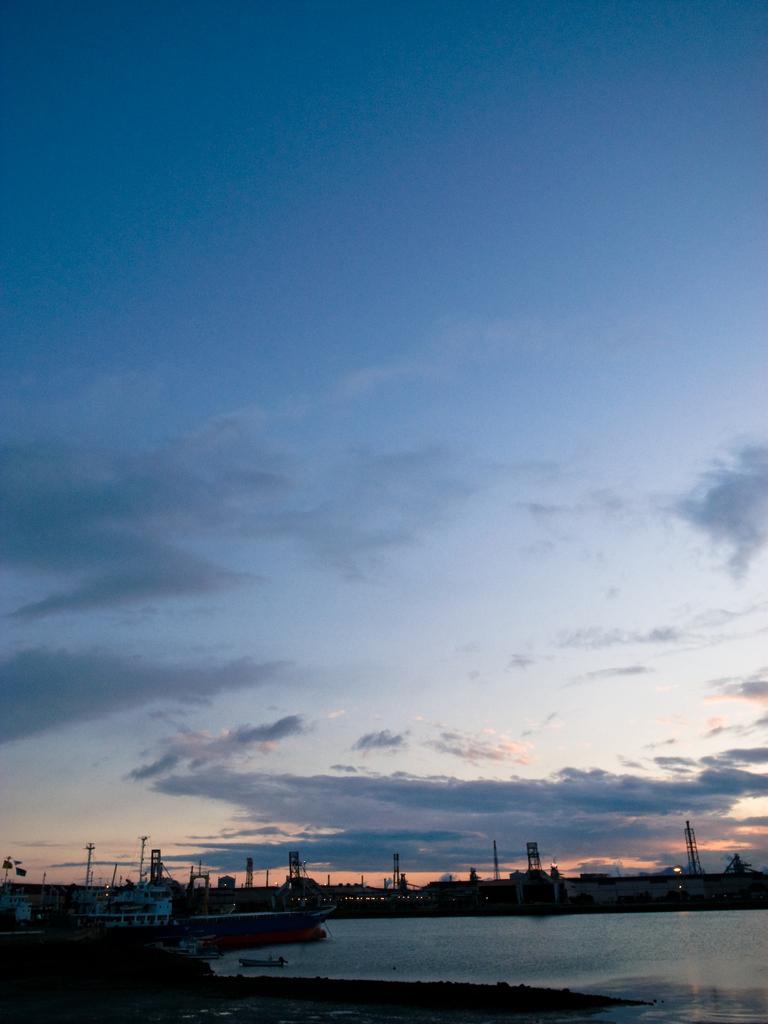How would you summarize this image in a sentence or two? In this picture i can see many towers, poles, ropes, wires and boats. At the bottom there is a water. In the center i can see the sky and clouds. 